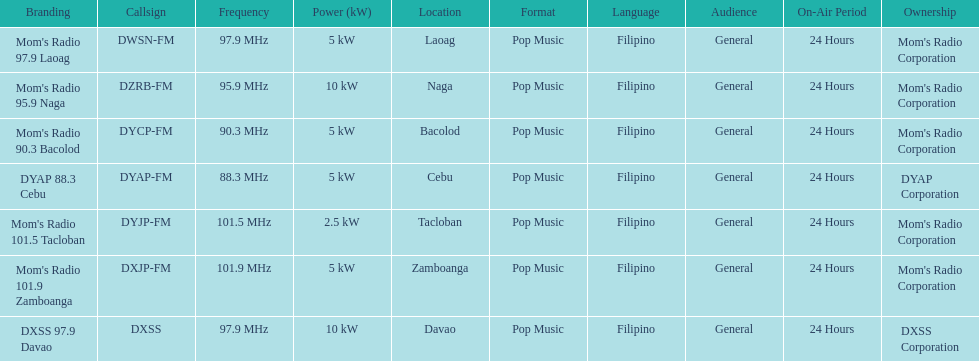How many times is the frequency greater than 95? 5. 